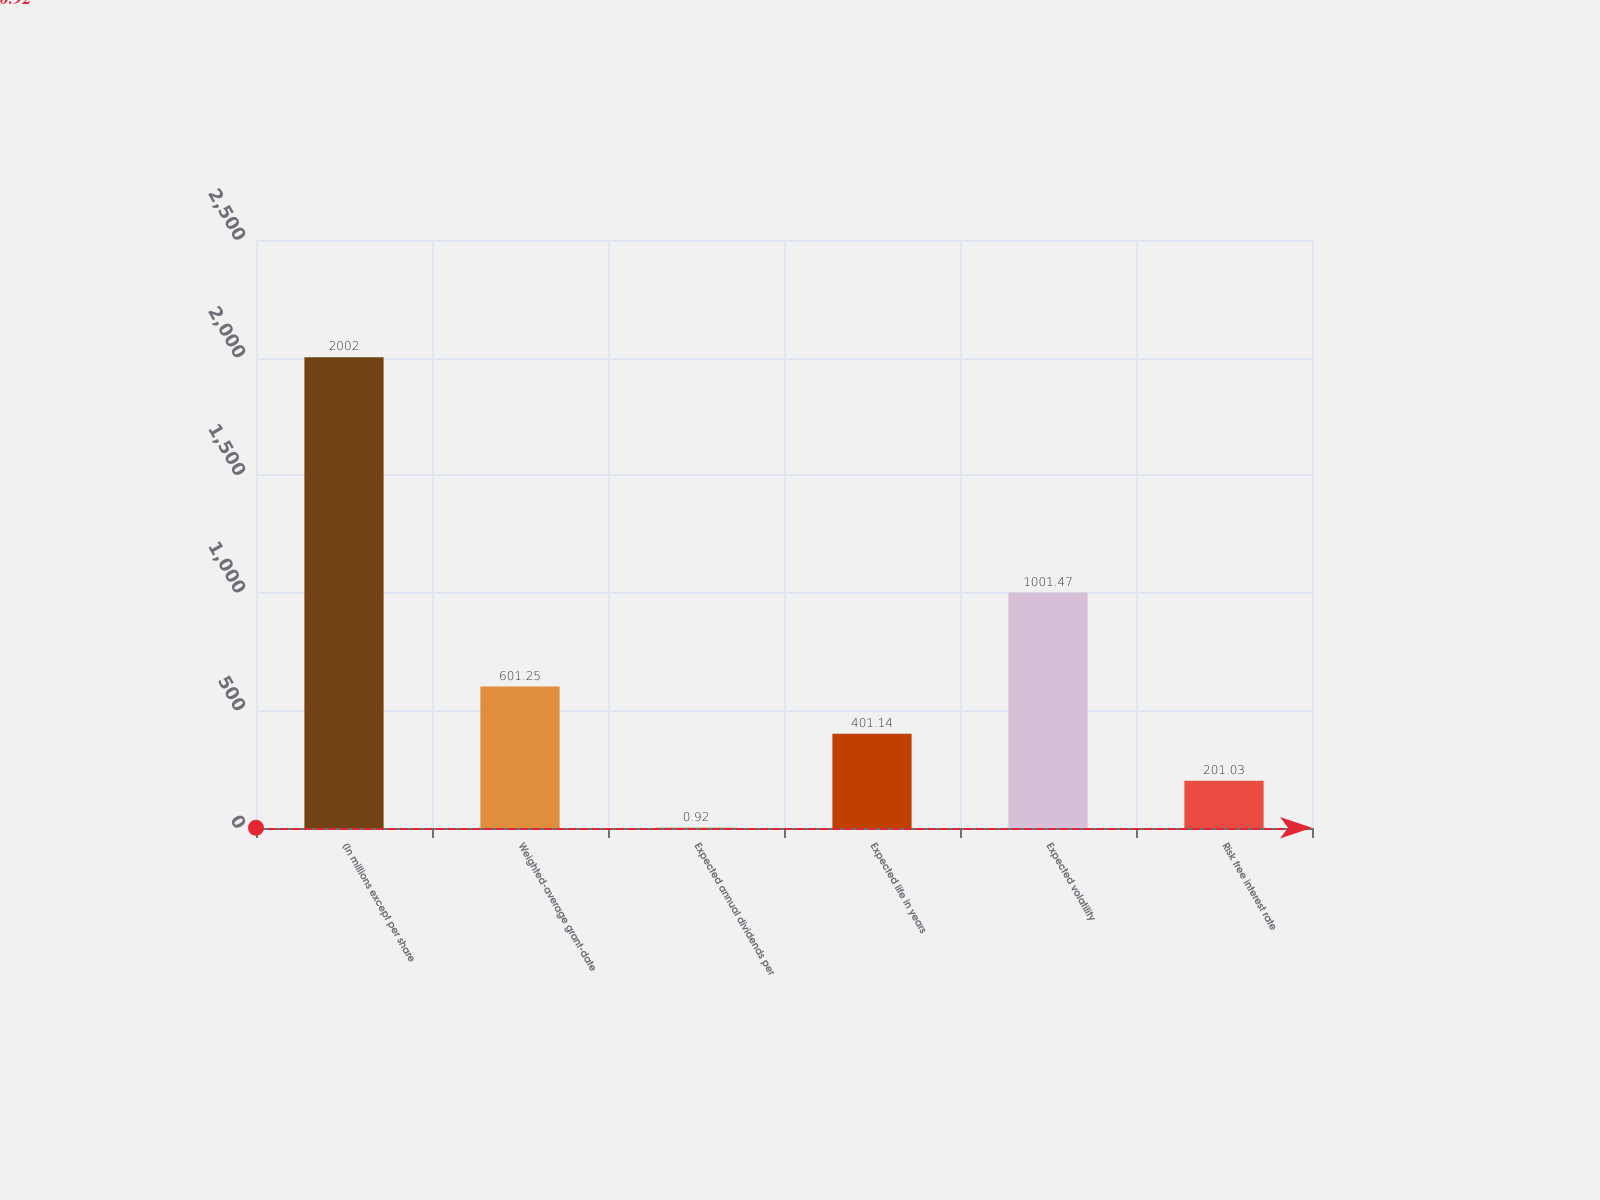<chart> <loc_0><loc_0><loc_500><loc_500><bar_chart><fcel>(In millions except per share<fcel>Weighted-average grant-date<fcel>Expected annual dividends per<fcel>Expected life in years<fcel>Expected volatility<fcel>Risk free interest rate<nl><fcel>2002<fcel>601.25<fcel>0.92<fcel>401.14<fcel>1001.47<fcel>201.03<nl></chart> 